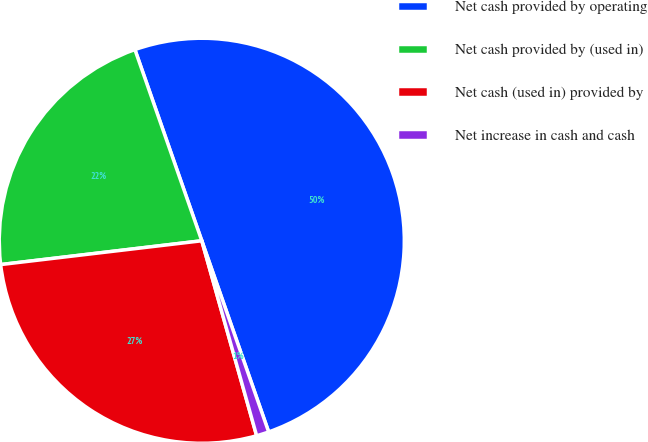<chart> <loc_0><loc_0><loc_500><loc_500><pie_chart><fcel>Net cash provided by operating<fcel>Net cash provided by (used in)<fcel>Net cash (used in) provided by<fcel>Net increase in cash and cash<nl><fcel>50.0%<fcel>21.52%<fcel>27.49%<fcel>0.99%<nl></chart> 